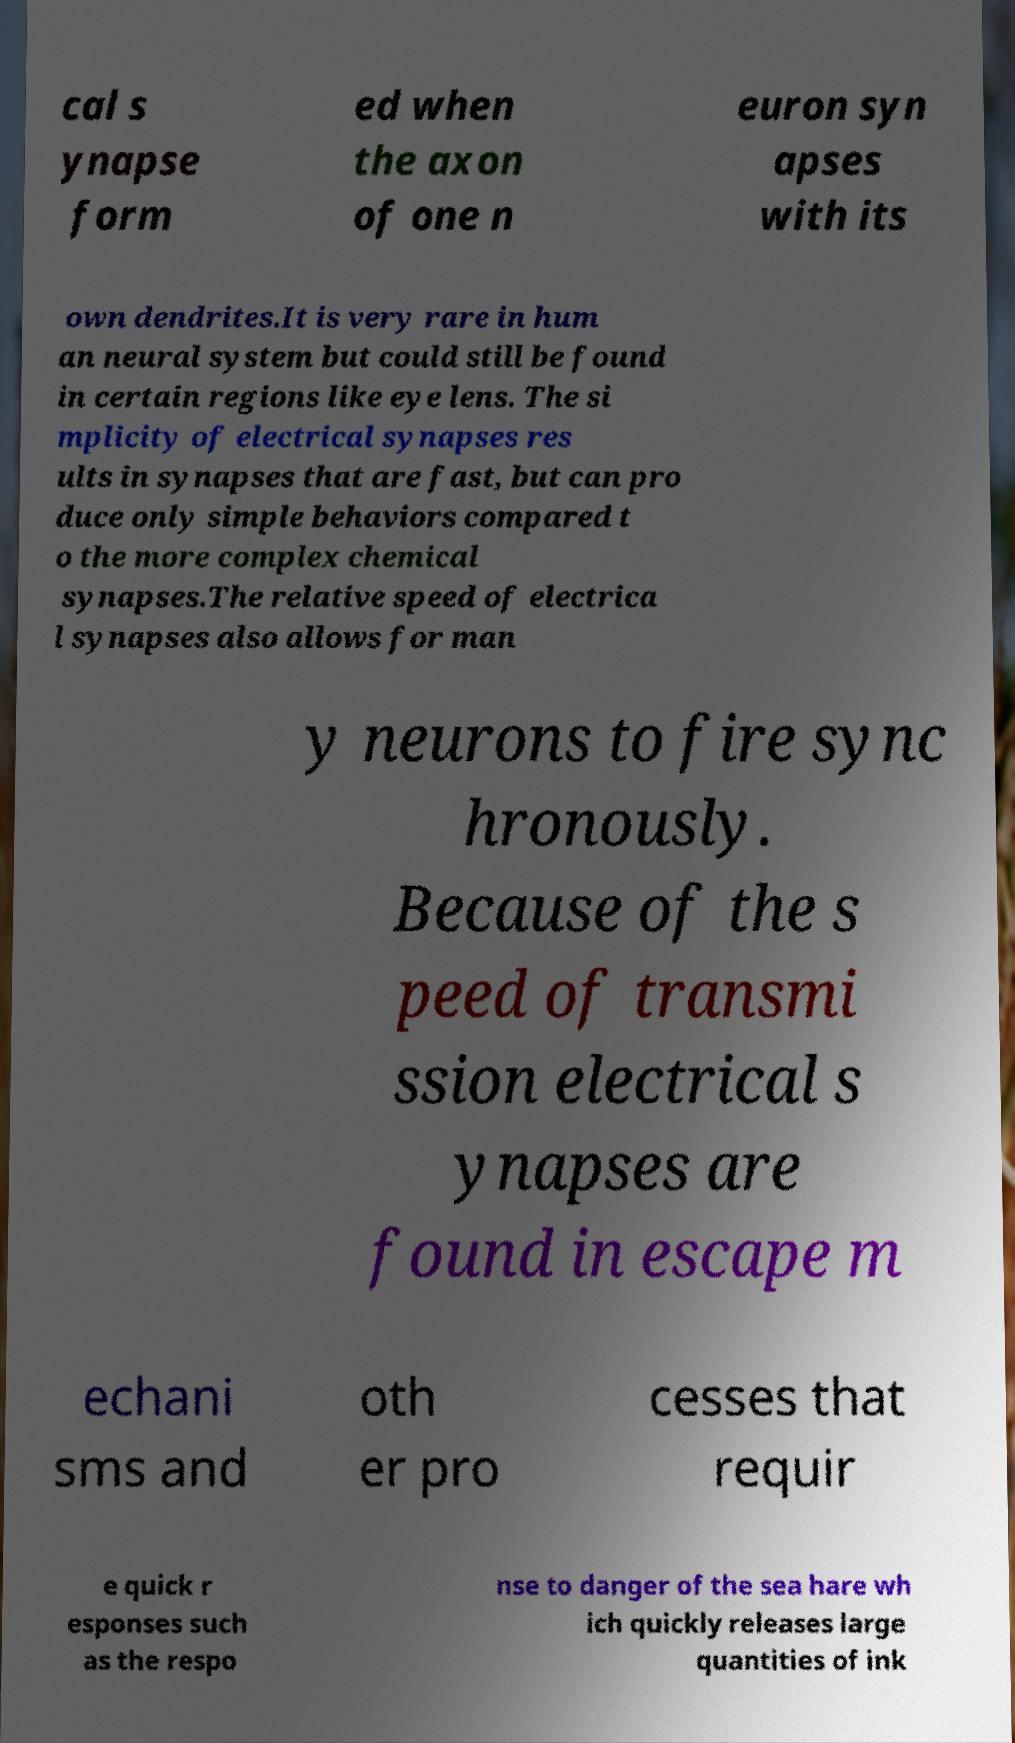Please read and relay the text visible in this image. What does it say? cal s ynapse form ed when the axon of one n euron syn apses with its own dendrites.It is very rare in hum an neural system but could still be found in certain regions like eye lens. The si mplicity of electrical synapses res ults in synapses that are fast, but can pro duce only simple behaviors compared t o the more complex chemical synapses.The relative speed of electrica l synapses also allows for man y neurons to fire sync hronously. Because of the s peed of transmi ssion electrical s ynapses are found in escape m echani sms and oth er pro cesses that requir e quick r esponses such as the respo nse to danger of the sea hare wh ich quickly releases large quantities of ink 